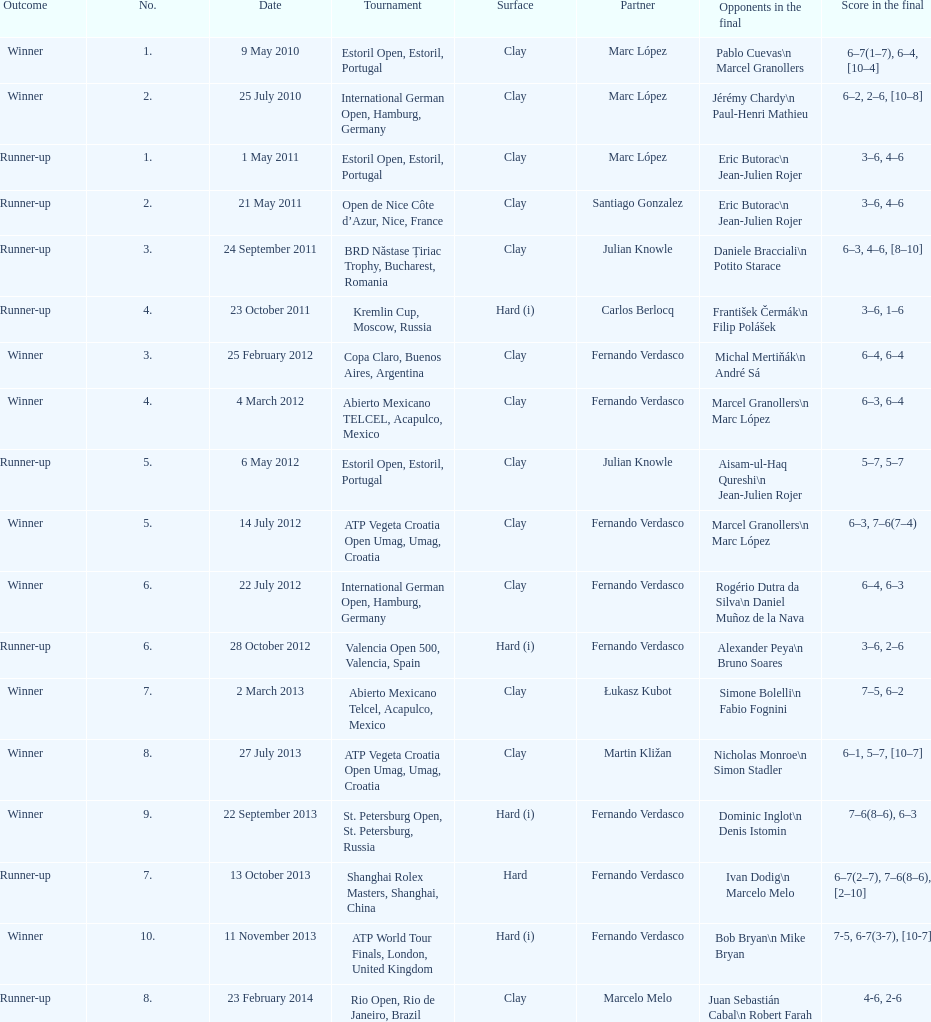Which tournament has the largest number? ATP World Tour Finals. Can you give me this table as a dict? {'header': ['Outcome', 'No.', 'Date', 'Tournament', 'Surface', 'Partner', 'Opponents in the final', 'Score in the final'], 'rows': [['Winner', '1.', '9 May 2010', 'Estoril Open, Estoril, Portugal', 'Clay', 'Marc López', 'Pablo Cuevas\\n Marcel Granollers', '6–7(1–7), 6–4, [10–4]'], ['Winner', '2.', '25 July 2010', 'International German Open, Hamburg, Germany', 'Clay', 'Marc López', 'Jérémy Chardy\\n Paul-Henri Mathieu', '6–2, 2–6, [10–8]'], ['Runner-up', '1.', '1 May 2011', 'Estoril Open, Estoril, Portugal', 'Clay', 'Marc López', 'Eric Butorac\\n Jean-Julien Rojer', '3–6, 4–6'], ['Runner-up', '2.', '21 May 2011', 'Open de Nice Côte d’Azur, Nice, France', 'Clay', 'Santiago Gonzalez', 'Eric Butorac\\n Jean-Julien Rojer', '3–6, 4–6'], ['Runner-up', '3.', '24 September 2011', 'BRD Năstase Țiriac Trophy, Bucharest, Romania', 'Clay', 'Julian Knowle', 'Daniele Bracciali\\n Potito Starace', '6–3, 4–6, [8–10]'], ['Runner-up', '4.', '23 October 2011', 'Kremlin Cup, Moscow, Russia', 'Hard (i)', 'Carlos Berlocq', 'František Čermák\\n Filip Polášek', '3–6, 1–6'], ['Winner', '3.', '25 February 2012', 'Copa Claro, Buenos Aires, Argentina', 'Clay', 'Fernando Verdasco', 'Michal Mertiňák\\n André Sá', '6–4, 6–4'], ['Winner', '4.', '4 March 2012', 'Abierto Mexicano TELCEL, Acapulco, Mexico', 'Clay', 'Fernando Verdasco', 'Marcel Granollers\\n Marc López', '6–3, 6–4'], ['Runner-up', '5.', '6 May 2012', 'Estoril Open, Estoril, Portugal', 'Clay', 'Julian Knowle', 'Aisam-ul-Haq Qureshi\\n Jean-Julien Rojer', '5–7, 5–7'], ['Winner', '5.', '14 July 2012', 'ATP Vegeta Croatia Open Umag, Umag, Croatia', 'Clay', 'Fernando Verdasco', 'Marcel Granollers\\n Marc López', '6–3, 7–6(7–4)'], ['Winner', '6.', '22 July 2012', 'International German Open, Hamburg, Germany', 'Clay', 'Fernando Verdasco', 'Rogério Dutra da Silva\\n Daniel Muñoz de la Nava', '6–4, 6–3'], ['Runner-up', '6.', '28 October 2012', 'Valencia Open 500, Valencia, Spain', 'Hard (i)', 'Fernando Verdasco', 'Alexander Peya\\n Bruno Soares', '3–6, 2–6'], ['Winner', '7.', '2 March 2013', 'Abierto Mexicano Telcel, Acapulco, Mexico', 'Clay', 'Łukasz Kubot', 'Simone Bolelli\\n Fabio Fognini', '7–5, 6–2'], ['Winner', '8.', '27 July 2013', 'ATP Vegeta Croatia Open Umag, Umag, Croatia', 'Clay', 'Martin Kližan', 'Nicholas Monroe\\n Simon Stadler', '6–1, 5–7, [10–7]'], ['Winner', '9.', '22 September 2013', 'St. Petersburg Open, St. Petersburg, Russia', 'Hard (i)', 'Fernando Verdasco', 'Dominic Inglot\\n Denis Istomin', '7–6(8–6), 6–3'], ['Runner-up', '7.', '13 October 2013', 'Shanghai Rolex Masters, Shanghai, China', 'Hard', 'Fernando Verdasco', 'Ivan Dodig\\n Marcelo Melo', '6–7(2–7), 7–6(8–6), [2–10]'], ['Winner', '10.', '11 November 2013', 'ATP World Tour Finals, London, United Kingdom', 'Hard (i)', 'Fernando Verdasco', 'Bob Bryan\\n Mike Bryan', '7-5, 6-7(3-7), [10-7]'], ['Runner-up', '8.', '23 February 2014', 'Rio Open, Rio de Janeiro, Brazil', 'Clay', 'Marcelo Melo', 'Juan Sebastián Cabal\\n Robert Farah', '4-6, 2-6']]} 